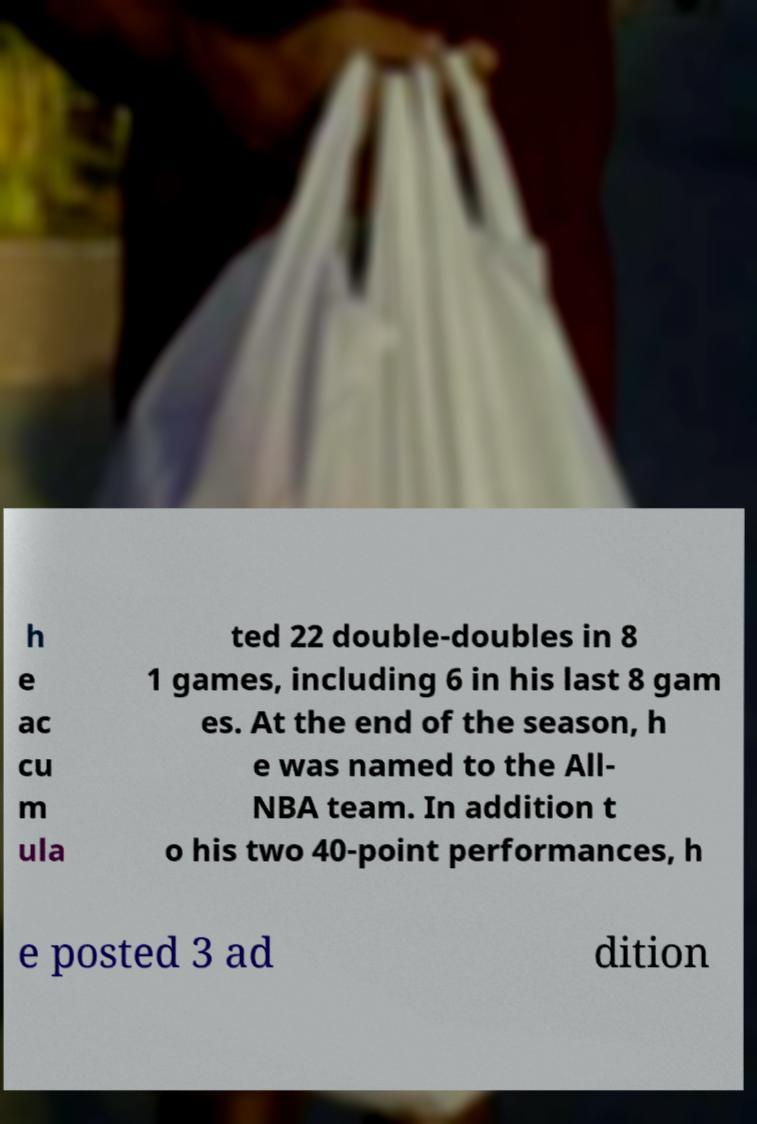Please identify and transcribe the text found in this image. h e ac cu m ula ted 22 double-doubles in 8 1 games, including 6 in his last 8 gam es. At the end of the season, h e was named to the All- NBA team. In addition t o his two 40-point performances, h e posted 3 ad dition 